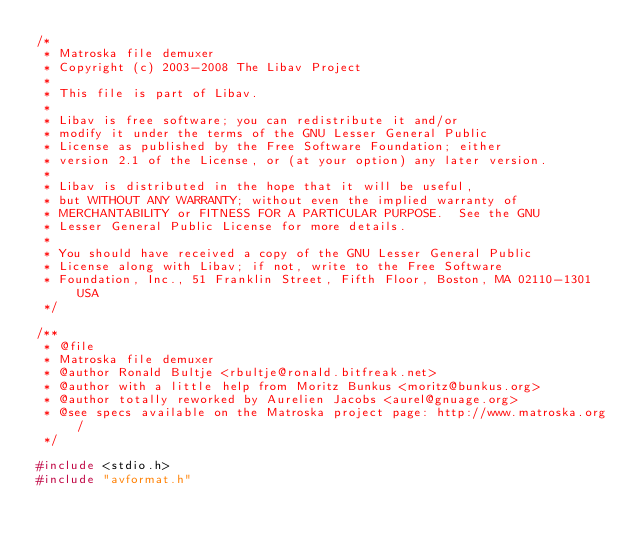Convert code to text. <code><loc_0><loc_0><loc_500><loc_500><_C_>/*
 * Matroska file demuxer
 * Copyright (c) 2003-2008 The Libav Project
 *
 * This file is part of Libav.
 *
 * Libav is free software; you can redistribute it and/or
 * modify it under the terms of the GNU Lesser General Public
 * License as published by the Free Software Foundation; either
 * version 2.1 of the License, or (at your option) any later version.
 *
 * Libav is distributed in the hope that it will be useful,
 * but WITHOUT ANY WARRANTY; without even the implied warranty of
 * MERCHANTABILITY or FITNESS FOR A PARTICULAR PURPOSE.  See the GNU
 * Lesser General Public License for more details.
 *
 * You should have received a copy of the GNU Lesser General Public
 * License along with Libav; if not, write to the Free Software
 * Foundation, Inc., 51 Franklin Street, Fifth Floor, Boston, MA 02110-1301 USA
 */

/**
 * @file
 * Matroska file demuxer
 * @author Ronald Bultje <rbultje@ronald.bitfreak.net>
 * @author with a little help from Moritz Bunkus <moritz@bunkus.org>
 * @author totally reworked by Aurelien Jacobs <aurel@gnuage.org>
 * @see specs available on the Matroska project page: http://www.matroska.org/
 */

#include <stdio.h>
#include "avformat.h"</code> 